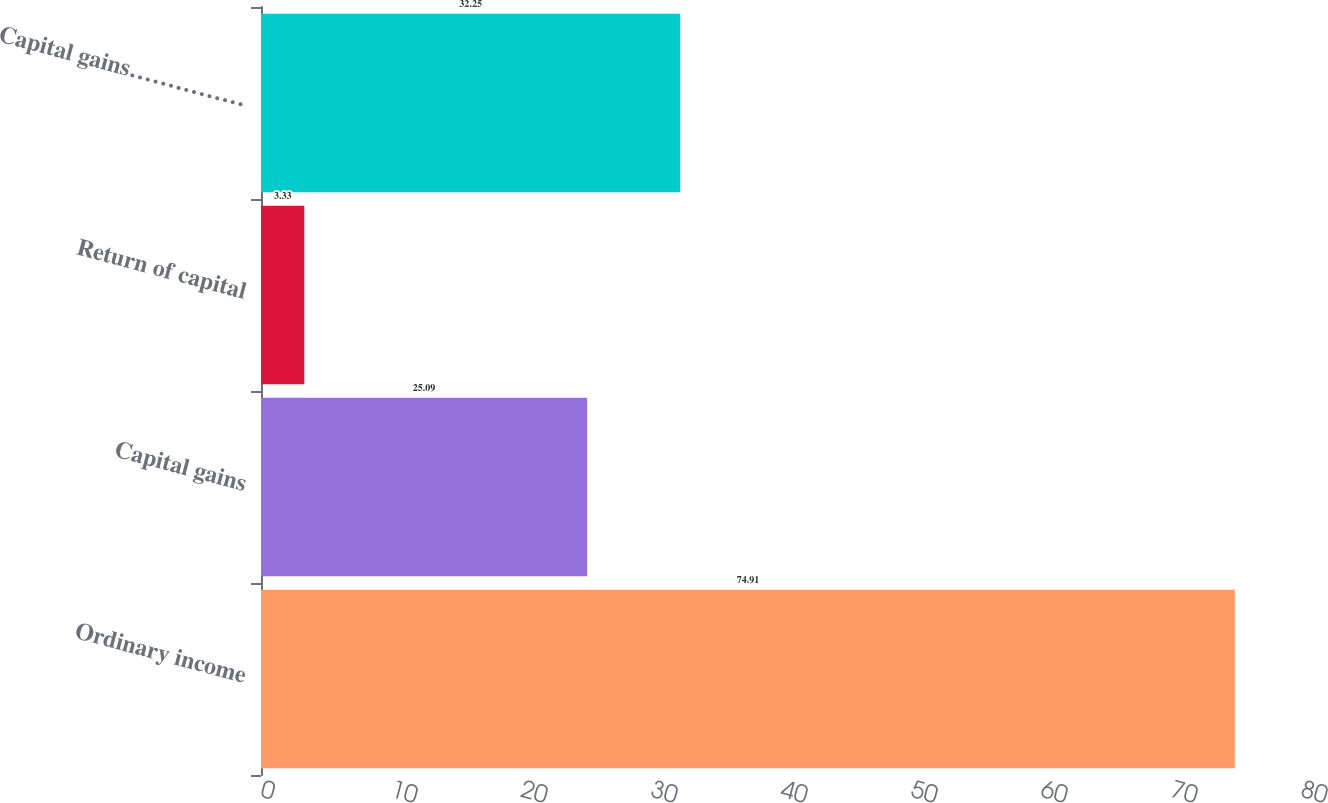<chart> <loc_0><loc_0><loc_500><loc_500><bar_chart><fcel>Ordinary income<fcel>Capital gains<fcel>Return of capital<fcel>Capital gains……………<nl><fcel>74.91<fcel>25.09<fcel>3.33<fcel>32.25<nl></chart> 